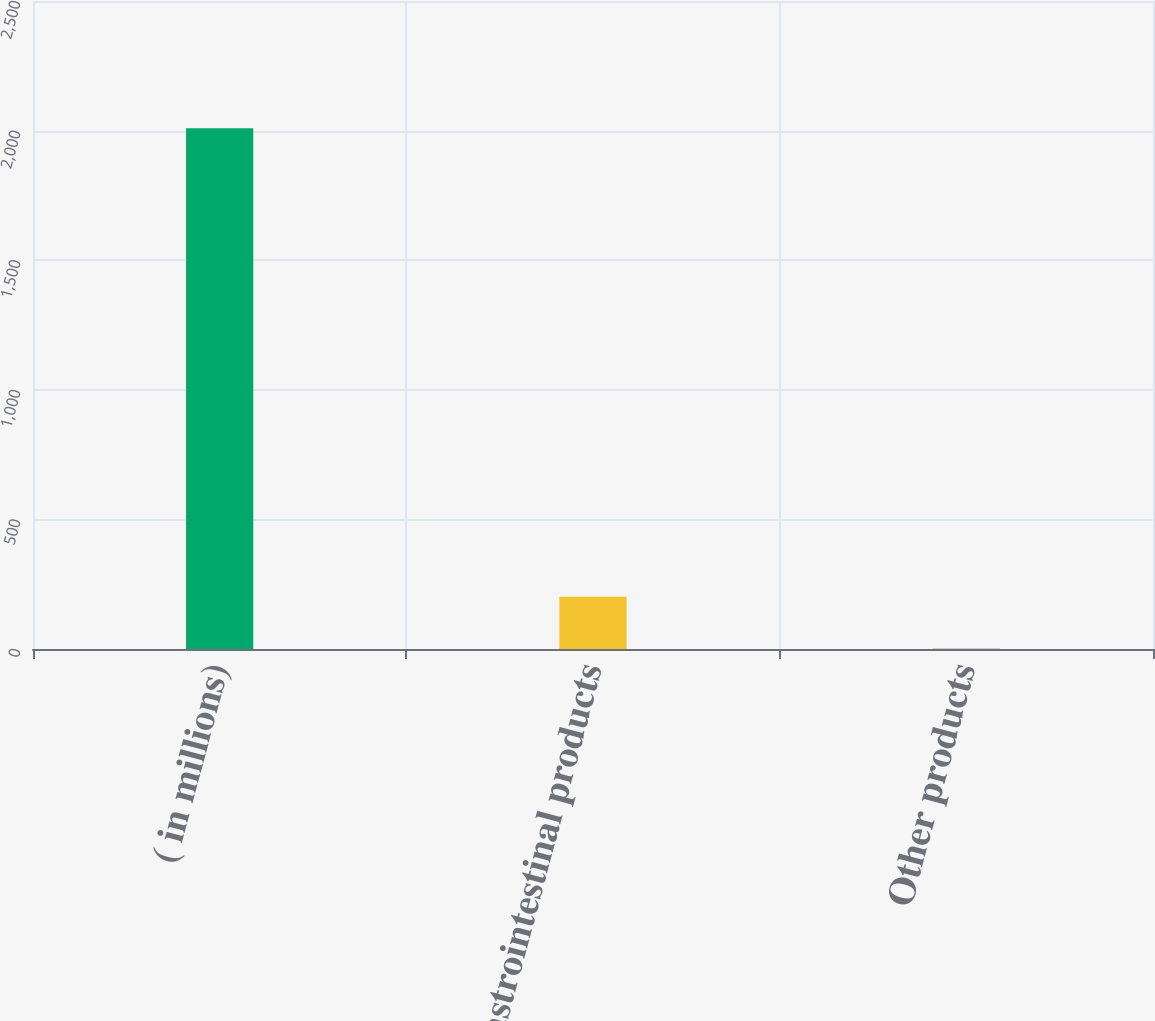Convert chart. <chart><loc_0><loc_0><loc_500><loc_500><bar_chart><fcel>( in millions)<fcel>Gastrointestinal products<fcel>Other products<nl><fcel>2009<fcel>202<fcel>1<nl></chart> 